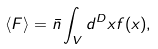Convert formula to latex. <formula><loc_0><loc_0><loc_500><loc_500>\langle F \rangle = { \bar { n } } \int _ { V } d ^ { D } x f ( x ) ,</formula> 